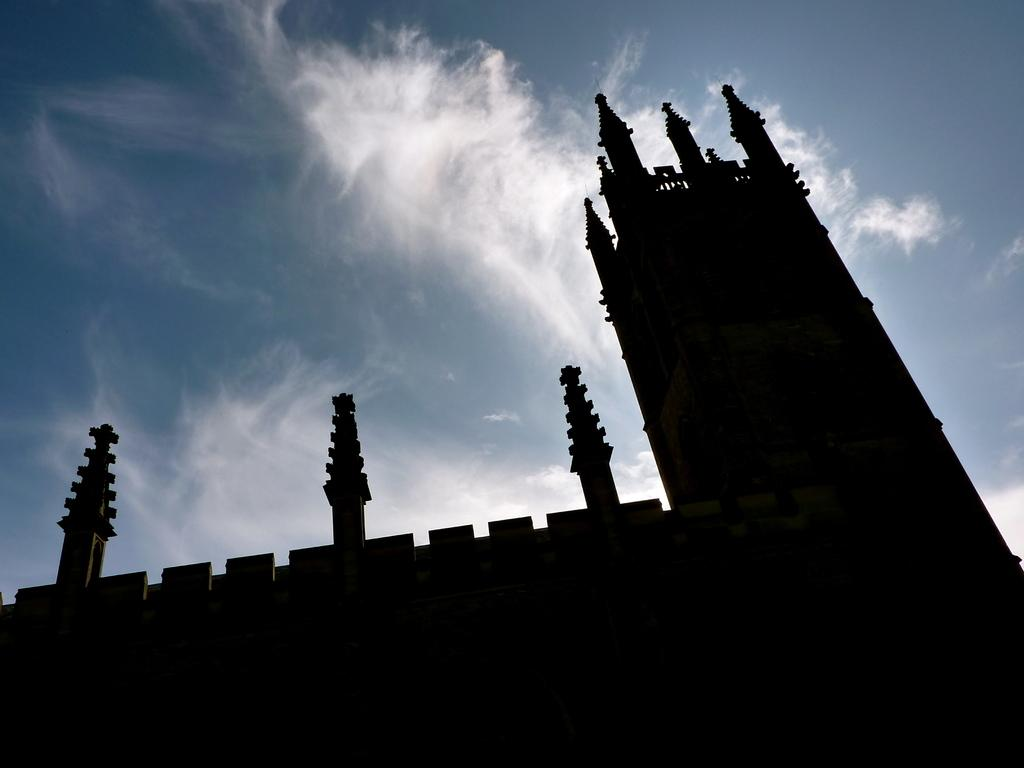What type of structure is present in the image? There is a building in the image. What can be seen in the background of the image? The sky is visible in the background of the image. How many elbows can be seen on the yak in the image? There is no yak present in the image, so it is not possible to determine the number of elbows. 